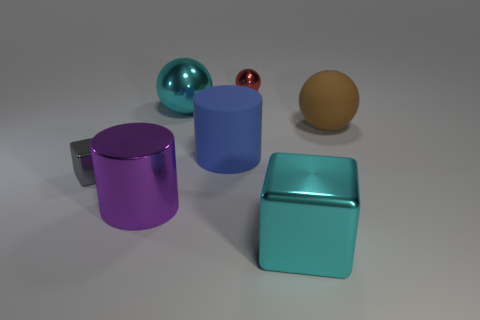Subtract all metal balls. How many balls are left? 1 Subtract all cyan cubes. How many cubes are left? 1 Subtract 1 cylinders. How many cylinders are left? 1 Subtract all blue cylinders. How many cyan cubes are left? 1 Subtract all big blue rubber things. Subtract all large cyan metal things. How many objects are left? 4 Add 6 small gray metallic things. How many small gray metallic things are left? 7 Add 6 cyan rubber cubes. How many cyan rubber cubes exist? 6 Add 3 small matte cubes. How many objects exist? 10 Subtract 0 yellow blocks. How many objects are left? 7 Subtract all cylinders. How many objects are left? 5 